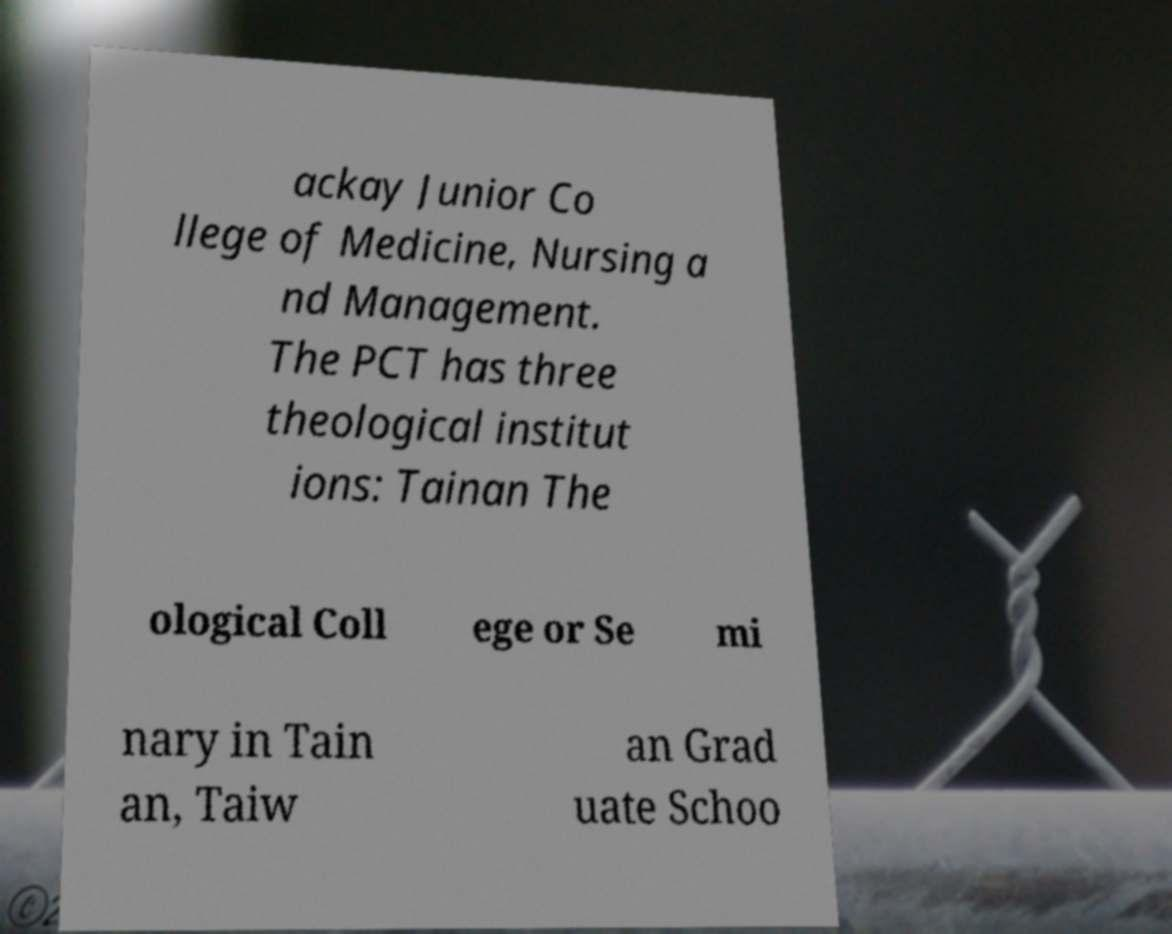I need the written content from this picture converted into text. Can you do that? ackay Junior Co llege of Medicine, Nursing a nd Management. The PCT has three theological institut ions: Tainan The ological Coll ege or Se mi nary in Tain an, Taiw an Grad uate Schoo 